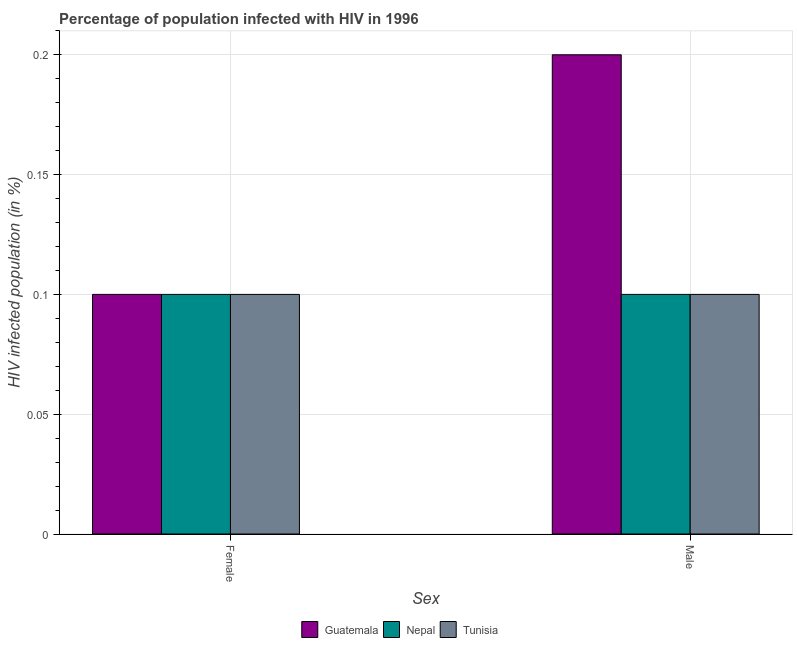How many groups of bars are there?
Offer a terse response. 2. Are the number of bars per tick equal to the number of legend labels?
Keep it short and to the point. Yes. How many bars are there on the 2nd tick from the right?
Make the answer very short. 3. What is the percentage of males who are infected with hiv in Nepal?
Provide a succinct answer. 0.1. In which country was the percentage of males who are infected with hiv maximum?
Your answer should be very brief. Guatemala. In which country was the percentage of males who are infected with hiv minimum?
Provide a short and direct response. Nepal. What is the total percentage of males who are infected with hiv in the graph?
Ensure brevity in your answer.  0.4. What is the difference between the percentage of males who are infected with hiv in Tunisia and that in Guatemala?
Make the answer very short. -0.1. What is the difference between the percentage of males who are infected with hiv in Tunisia and the percentage of females who are infected with hiv in Nepal?
Your answer should be compact. 0. What is the average percentage of males who are infected with hiv per country?
Offer a terse response. 0.13. In how many countries, is the percentage of females who are infected with hiv greater than 0.060000000000000005 %?
Make the answer very short. 3. What is the ratio of the percentage of females who are infected with hiv in Guatemala to that in Tunisia?
Provide a succinct answer. 1. Is the percentage of males who are infected with hiv in Guatemala less than that in Nepal?
Ensure brevity in your answer.  No. In how many countries, is the percentage of males who are infected with hiv greater than the average percentage of males who are infected with hiv taken over all countries?
Offer a terse response. 1. What does the 3rd bar from the left in Male represents?
Your answer should be very brief. Tunisia. What does the 2nd bar from the right in Female represents?
Your answer should be very brief. Nepal. How many bars are there?
Keep it short and to the point. 6. Are all the bars in the graph horizontal?
Your answer should be compact. No. What is the difference between two consecutive major ticks on the Y-axis?
Keep it short and to the point. 0.05. Are the values on the major ticks of Y-axis written in scientific E-notation?
Keep it short and to the point. No. Does the graph contain grids?
Make the answer very short. Yes. How are the legend labels stacked?
Offer a very short reply. Horizontal. What is the title of the graph?
Your answer should be very brief. Percentage of population infected with HIV in 1996. Does "Sudan" appear as one of the legend labels in the graph?
Provide a succinct answer. No. What is the label or title of the X-axis?
Your response must be concise. Sex. What is the label or title of the Y-axis?
Provide a short and direct response. HIV infected population (in %). What is the HIV infected population (in %) in Guatemala in Female?
Make the answer very short. 0.1. What is the HIV infected population (in %) in Tunisia in Female?
Make the answer very short. 0.1. What is the HIV infected population (in %) of Tunisia in Male?
Your answer should be very brief. 0.1. Across all Sex, what is the maximum HIV infected population (in %) in Nepal?
Offer a very short reply. 0.1. Across all Sex, what is the maximum HIV infected population (in %) in Tunisia?
Offer a terse response. 0.1. Across all Sex, what is the minimum HIV infected population (in %) of Guatemala?
Ensure brevity in your answer.  0.1. Across all Sex, what is the minimum HIV infected population (in %) in Nepal?
Ensure brevity in your answer.  0.1. What is the total HIV infected population (in %) in Tunisia in the graph?
Keep it short and to the point. 0.2. What is the difference between the HIV infected population (in %) in Tunisia in Female and that in Male?
Offer a terse response. 0. What is the difference between the HIV infected population (in %) of Guatemala in Female and the HIV infected population (in %) of Nepal in Male?
Give a very brief answer. 0. What is the difference between the HIV infected population (in %) in Guatemala in Female and the HIV infected population (in %) in Tunisia in Male?
Provide a succinct answer. 0. What is the average HIV infected population (in %) in Tunisia per Sex?
Keep it short and to the point. 0.1. What is the difference between the HIV infected population (in %) of Guatemala and HIV infected population (in %) of Tunisia in Female?
Keep it short and to the point. 0. What is the difference between the HIV infected population (in %) of Guatemala and HIV infected population (in %) of Nepal in Male?
Keep it short and to the point. 0.1. What is the difference between the HIV infected population (in %) in Guatemala and HIV infected population (in %) in Tunisia in Male?
Provide a succinct answer. 0.1. What is the ratio of the HIV infected population (in %) of Guatemala in Female to that in Male?
Make the answer very short. 0.5. What is the ratio of the HIV infected population (in %) of Nepal in Female to that in Male?
Keep it short and to the point. 1. What is the ratio of the HIV infected population (in %) of Tunisia in Female to that in Male?
Your response must be concise. 1. What is the difference between the highest and the second highest HIV infected population (in %) of Nepal?
Offer a very short reply. 0. What is the difference between the highest and the second highest HIV infected population (in %) in Tunisia?
Keep it short and to the point. 0. 